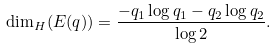<formula> <loc_0><loc_0><loc_500><loc_500>\dim _ { H } ( E ( q ) ) = \frac { - q _ { 1 } \log { q _ { 1 } } - q _ { 2 } \log { q _ { 2 } } } { \log { 2 } } .</formula> 